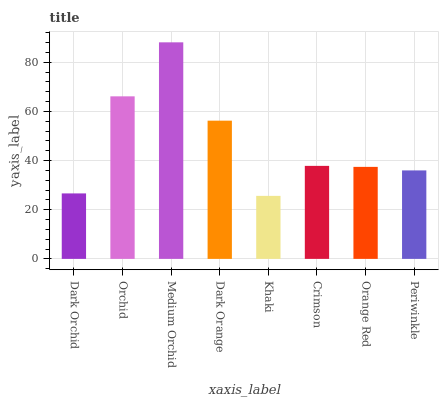Is Khaki the minimum?
Answer yes or no. Yes. Is Medium Orchid the maximum?
Answer yes or no. Yes. Is Orchid the minimum?
Answer yes or no. No. Is Orchid the maximum?
Answer yes or no. No. Is Orchid greater than Dark Orchid?
Answer yes or no. Yes. Is Dark Orchid less than Orchid?
Answer yes or no. Yes. Is Dark Orchid greater than Orchid?
Answer yes or no. No. Is Orchid less than Dark Orchid?
Answer yes or no. No. Is Crimson the high median?
Answer yes or no. Yes. Is Orange Red the low median?
Answer yes or no. Yes. Is Medium Orchid the high median?
Answer yes or no. No. Is Periwinkle the low median?
Answer yes or no. No. 